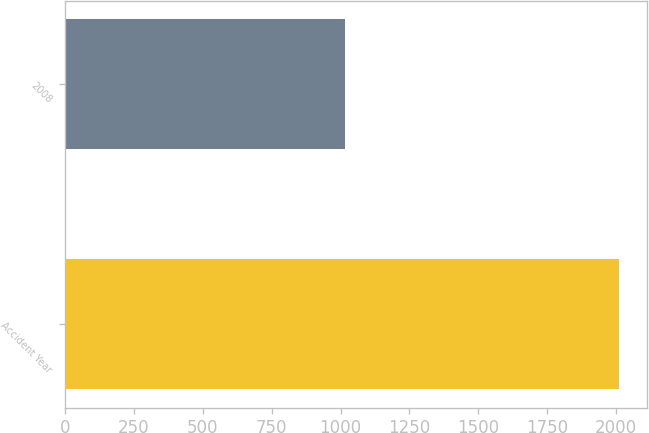Convert chart to OTSL. <chart><loc_0><loc_0><loc_500><loc_500><bar_chart><fcel>Accident Year<fcel>2008<nl><fcel>2012<fcel>1015<nl></chart> 